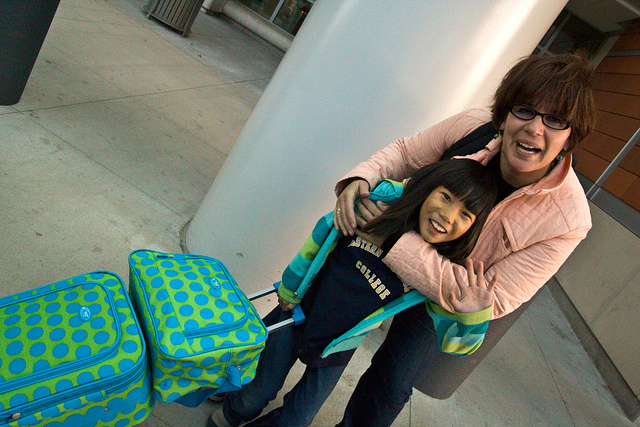What time of day does it appear to be in the image? Based on the lighting and the long shadows visible on the ground, it seems to be either early morning or late afternoon. Such times of day are often chosen for travel to make the most of the daylight hours or to catch a flight scheduled during these times. 